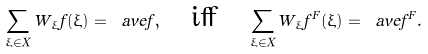<formula> <loc_0><loc_0><loc_500><loc_500>\sum _ { \xi \in X } W _ { \xi } f ( \xi ) = \ a v e { f } , \quad \text {iff} \quad \sum _ { \xi \in X } W _ { \xi } f ^ { F } ( \xi ) = \ a v e { f ^ { F } } .</formula> 